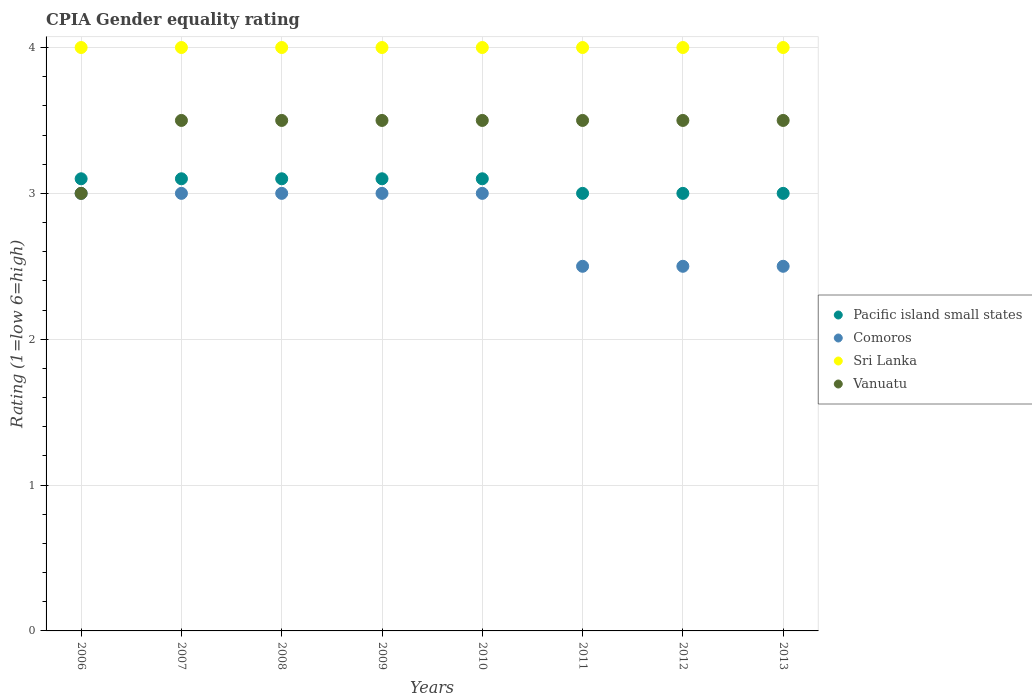What is the CPIA rating in Pacific island small states in 2007?
Your response must be concise. 3.1. What is the difference between the CPIA rating in Pacific island small states in 2010 and the CPIA rating in Vanuatu in 2012?
Provide a succinct answer. -0.4. What is the average CPIA rating in Sri Lanka per year?
Offer a terse response. 4. What is the ratio of the CPIA rating in Sri Lanka in 2009 to that in 2010?
Keep it short and to the point. 1. What is the difference between the highest and the second highest CPIA rating in Pacific island small states?
Provide a short and direct response. 0. What is the difference between the highest and the lowest CPIA rating in Pacific island small states?
Make the answer very short. 0.1. In how many years, is the CPIA rating in Comoros greater than the average CPIA rating in Comoros taken over all years?
Ensure brevity in your answer.  5. Is the CPIA rating in Sri Lanka strictly greater than the CPIA rating in Vanuatu over the years?
Your answer should be very brief. Yes. Is the CPIA rating in Pacific island small states strictly less than the CPIA rating in Comoros over the years?
Make the answer very short. No. How many years are there in the graph?
Provide a succinct answer. 8. What is the difference between two consecutive major ticks on the Y-axis?
Provide a short and direct response. 1. Are the values on the major ticks of Y-axis written in scientific E-notation?
Provide a short and direct response. No. Where does the legend appear in the graph?
Your response must be concise. Center right. How are the legend labels stacked?
Provide a short and direct response. Vertical. What is the title of the graph?
Offer a very short reply. CPIA Gender equality rating. Does "Guam" appear as one of the legend labels in the graph?
Provide a short and direct response. No. What is the label or title of the Y-axis?
Offer a very short reply. Rating (1=low 6=high). What is the Rating (1=low 6=high) in Comoros in 2006?
Provide a succinct answer. 3. What is the Rating (1=low 6=high) of Vanuatu in 2006?
Offer a terse response. 3. What is the Rating (1=low 6=high) in Pacific island small states in 2007?
Provide a short and direct response. 3.1. What is the Rating (1=low 6=high) in Comoros in 2007?
Provide a succinct answer. 3. What is the Rating (1=low 6=high) in Sri Lanka in 2007?
Give a very brief answer. 4. What is the Rating (1=low 6=high) of Pacific island small states in 2008?
Offer a terse response. 3.1. What is the Rating (1=low 6=high) in Comoros in 2008?
Provide a succinct answer. 3. What is the Rating (1=low 6=high) in Vanuatu in 2008?
Provide a succinct answer. 3.5. What is the Rating (1=low 6=high) of Sri Lanka in 2010?
Provide a short and direct response. 4. What is the Rating (1=low 6=high) of Vanuatu in 2010?
Your response must be concise. 3.5. What is the Rating (1=low 6=high) in Pacific island small states in 2011?
Provide a succinct answer. 3. What is the Rating (1=low 6=high) in Sri Lanka in 2011?
Your answer should be compact. 4. What is the Rating (1=low 6=high) of Vanuatu in 2011?
Your response must be concise. 3.5. What is the Rating (1=low 6=high) in Vanuatu in 2012?
Your response must be concise. 3.5. Across all years, what is the maximum Rating (1=low 6=high) in Pacific island small states?
Offer a very short reply. 3.1. Across all years, what is the minimum Rating (1=low 6=high) of Sri Lanka?
Provide a succinct answer. 4. What is the total Rating (1=low 6=high) of Comoros in the graph?
Your response must be concise. 22.5. What is the total Rating (1=low 6=high) of Sri Lanka in the graph?
Offer a terse response. 32. What is the difference between the Rating (1=low 6=high) in Pacific island small states in 2006 and that in 2007?
Offer a terse response. 0. What is the difference between the Rating (1=low 6=high) in Comoros in 2006 and that in 2007?
Provide a succinct answer. 0. What is the difference between the Rating (1=low 6=high) of Pacific island small states in 2006 and that in 2008?
Ensure brevity in your answer.  0. What is the difference between the Rating (1=low 6=high) of Comoros in 2006 and that in 2008?
Provide a short and direct response. 0. What is the difference between the Rating (1=low 6=high) of Vanuatu in 2006 and that in 2008?
Provide a short and direct response. -0.5. What is the difference between the Rating (1=low 6=high) in Pacific island small states in 2006 and that in 2009?
Give a very brief answer. 0. What is the difference between the Rating (1=low 6=high) in Pacific island small states in 2006 and that in 2010?
Keep it short and to the point. 0. What is the difference between the Rating (1=low 6=high) in Pacific island small states in 2006 and that in 2011?
Ensure brevity in your answer.  0.1. What is the difference between the Rating (1=low 6=high) of Vanuatu in 2006 and that in 2011?
Your answer should be compact. -0.5. What is the difference between the Rating (1=low 6=high) of Comoros in 2006 and that in 2012?
Ensure brevity in your answer.  0.5. What is the difference between the Rating (1=low 6=high) of Vanuatu in 2006 and that in 2012?
Provide a succinct answer. -0.5. What is the difference between the Rating (1=low 6=high) in Pacific island small states in 2006 and that in 2013?
Ensure brevity in your answer.  0.1. What is the difference between the Rating (1=low 6=high) of Sri Lanka in 2006 and that in 2013?
Your answer should be compact. 0. What is the difference between the Rating (1=low 6=high) in Comoros in 2007 and that in 2008?
Make the answer very short. 0. What is the difference between the Rating (1=low 6=high) in Pacific island small states in 2007 and that in 2009?
Make the answer very short. 0. What is the difference between the Rating (1=low 6=high) of Vanuatu in 2007 and that in 2009?
Ensure brevity in your answer.  0. What is the difference between the Rating (1=low 6=high) in Pacific island small states in 2007 and that in 2010?
Offer a very short reply. 0. What is the difference between the Rating (1=low 6=high) in Sri Lanka in 2007 and that in 2010?
Your answer should be very brief. 0. What is the difference between the Rating (1=low 6=high) of Sri Lanka in 2007 and that in 2011?
Provide a short and direct response. 0. What is the difference between the Rating (1=low 6=high) of Vanuatu in 2007 and that in 2011?
Your answer should be very brief. 0. What is the difference between the Rating (1=low 6=high) of Sri Lanka in 2007 and that in 2012?
Provide a short and direct response. 0. What is the difference between the Rating (1=low 6=high) of Vanuatu in 2007 and that in 2012?
Your response must be concise. 0. What is the difference between the Rating (1=low 6=high) of Pacific island small states in 2007 and that in 2013?
Your answer should be compact. 0.1. What is the difference between the Rating (1=low 6=high) in Sri Lanka in 2007 and that in 2013?
Offer a terse response. 0. What is the difference between the Rating (1=low 6=high) in Comoros in 2008 and that in 2009?
Keep it short and to the point. 0. What is the difference between the Rating (1=low 6=high) in Sri Lanka in 2008 and that in 2010?
Your answer should be compact. 0. What is the difference between the Rating (1=low 6=high) in Vanuatu in 2008 and that in 2010?
Offer a terse response. 0. What is the difference between the Rating (1=low 6=high) in Pacific island small states in 2008 and that in 2011?
Ensure brevity in your answer.  0.1. What is the difference between the Rating (1=low 6=high) in Comoros in 2008 and that in 2011?
Your answer should be compact. 0.5. What is the difference between the Rating (1=low 6=high) of Comoros in 2008 and that in 2012?
Give a very brief answer. 0.5. What is the difference between the Rating (1=low 6=high) of Sri Lanka in 2008 and that in 2012?
Provide a succinct answer. 0. What is the difference between the Rating (1=low 6=high) in Pacific island small states in 2009 and that in 2010?
Provide a short and direct response. 0. What is the difference between the Rating (1=low 6=high) in Comoros in 2009 and that in 2010?
Offer a terse response. 0. What is the difference between the Rating (1=low 6=high) of Vanuatu in 2009 and that in 2010?
Your answer should be compact. 0. What is the difference between the Rating (1=low 6=high) in Pacific island small states in 2009 and that in 2011?
Ensure brevity in your answer.  0.1. What is the difference between the Rating (1=low 6=high) in Comoros in 2009 and that in 2011?
Keep it short and to the point. 0.5. What is the difference between the Rating (1=low 6=high) of Vanuatu in 2009 and that in 2011?
Give a very brief answer. 0. What is the difference between the Rating (1=low 6=high) in Pacific island small states in 2009 and that in 2012?
Keep it short and to the point. 0.1. What is the difference between the Rating (1=low 6=high) in Sri Lanka in 2009 and that in 2012?
Your answer should be very brief. 0. What is the difference between the Rating (1=low 6=high) of Vanuatu in 2009 and that in 2012?
Give a very brief answer. 0. What is the difference between the Rating (1=low 6=high) of Pacific island small states in 2009 and that in 2013?
Offer a terse response. 0.1. What is the difference between the Rating (1=low 6=high) in Comoros in 2009 and that in 2013?
Make the answer very short. 0.5. What is the difference between the Rating (1=low 6=high) in Sri Lanka in 2009 and that in 2013?
Provide a short and direct response. 0. What is the difference between the Rating (1=low 6=high) of Vanuatu in 2009 and that in 2013?
Provide a short and direct response. 0. What is the difference between the Rating (1=low 6=high) of Pacific island small states in 2010 and that in 2011?
Give a very brief answer. 0.1. What is the difference between the Rating (1=low 6=high) of Comoros in 2010 and that in 2011?
Give a very brief answer. 0.5. What is the difference between the Rating (1=low 6=high) of Sri Lanka in 2010 and that in 2011?
Ensure brevity in your answer.  0. What is the difference between the Rating (1=low 6=high) in Pacific island small states in 2010 and that in 2012?
Your response must be concise. 0.1. What is the difference between the Rating (1=low 6=high) of Sri Lanka in 2010 and that in 2012?
Your response must be concise. 0. What is the difference between the Rating (1=low 6=high) of Vanuatu in 2010 and that in 2012?
Keep it short and to the point. 0. What is the difference between the Rating (1=low 6=high) of Pacific island small states in 2010 and that in 2013?
Ensure brevity in your answer.  0.1. What is the difference between the Rating (1=low 6=high) in Vanuatu in 2010 and that in 2013?
Provide a succinct answer. 0. What is the difference between the Rating (1=low 6=high) of Vanuatu in 2011 and that in 2013?
Your response must be concise. 0. What is the difference between the Rating (1=low 6=high) of Pacific island small states in 2012 and that in 2013?
Make the answer very short. 0. What is the difference between the Rating (1=low 6=high) in Vanuatu in 2012 and that in 2013?
Make the answer very short. 0. What is the difference between the Rating (1=low 6=high) in Pacific island small states in 2006 and the Rating (1=low 6=high) in Comoros in 2007?
Ensure brevity in your answer.  0.1. What is the difference between the Rating (1=low 6=high) in Pacific island small states in 2006 and the Rating (1=low 6=high) in Vanuatu in 2007?
Your answer should be very brief. -0.4. What is the difference between the Rating (1=low 6=high) of Pacific island small states in 2006 and the Rating (1=low 6=high) of Comoros in 2008?
Your answer should be compact. 0.1. What is the difference between the Rating (1=low 6=high) in Pacific island small states in 2006 and the Rating (1=low 6=high) in Vanuatu in 2008?
Give a very brief answer. -0.4. What is the difference between the Rating (1=low 6=high) of Comoros in 2006 and the Rating (1=low 6=high) of Sri Lanka in 2009?
Ensure brevity in your answer.  -1. What is the difference between the Rating (1=low 6=high) of Comoros in 2006 and the Rating (1=low 6=high) of Vanuatu in 2009?
Your answer should be very brief. -0.5. What is the difference between the Rating (1=low 6=high) of Sri Lanka in 2006 and the Rating (1=low 6=high) of Vanuatu in 2009?
Offer a terse response. 0.5. What is the difference between the Rating (1=low 6=high) of Pacific island small states in 2006 and the Rating (1=low 6=high) of Vanuatu in 2010?
Offer a terse response. -0.4. What is the difference between the Rating (1=low 6=high) of Comoros in 2006 and the Rating (1=low 6=high) of Sri Lanka in 2010?
Your response must be concise. -1. What is the difference between the Rating (1=low 6=high) in Comoros in 2006 and the Rating (1=low 6=high) in Vanuatu in 2010?
Make the answer very short. -0.5. What is the difference between the Rating (1=low 6=high) in Sri Lanka in 2006 and the Rating (1=low 6=high) in Vanuatu in 2010?
Make the answer very short. 0.5. What is the difference between the Rating (1=low 6=high) of Pacific island small states in 2006 and the Rating (1=low 6=high) of Comoros in 2011?
Offer a very short reply. 0.6. What is the difference between the Rating (1=low 6=high) in Comoros in 2006 and the Rating (1=low 6=high) in Vanuatu in 2011?
Keep it short and to the point. -0.5. What is the difference between the Rating (1=low 6=high) in Sri Lanka in 2006 and the Rating (1=low 6=high) in Vanuatu in 2011?
Your answer should be compact. 0.5. What is the difference between the Rating (1=low 6=high) in Sri Lanka in 2006 and the Rating (1=low 6=high) in Vanuatu in 2012?
Provide a short and direct response. 0.5. What is the difference between the Rating (1=low 6=high) of Pacific island small states in 2006 and the Rating (1=low 6=high) of Comoros in 2013?
Provide a short and direct response. 0.6. What is the difference between the Rating (1=low 6=high) of Pacific island small states in 2007 and the Rating (1=low 6=high) of Vanuatu in 2008?
Provide a short and direct response. -0.4. What is the difference between the Rating (1=low 6=high) of Sri Lanka in 2007 and the Rating (1=low 6=high) of Vanuatu in 2008?
Your answer should be very brief. 0.5. What is the difference between the Rating (1=low 6=high) of Pacific island small states in 2007 and the Rating (1=low 6=high) of Comoros in 2009?
Give a very brief answer. 0.1. What is the difference between the Rating (1=low 6=high) in Pacific island small states in 2007 and the Rating (1=low 6=high) in Sri Lanka in 2009?
Offer a terse response. -0.9. What is the difference between the Rating (1=low 6=high) in Pacific island small states in 2007 and the Rating (1=low 6=high) in Vanuatu in 2009?
Provide a succinct answer. -0.4. What is the difference between the Rating (1=low 6=high) in Pacific island small states in 2007 and the Rating (1=low 6=high) in Comoros in 2010?
Give a very brief answer. 0.1. What is the difference between the Rating (1=low 6=high) in Pacific island small states in 2007 and the Rating (1=low 6=high) in Sri Lanka in 2010?
Keep it short and to the point. -0.9. What is the difference between the Rating (1=low 6=high) of Pacific island small states in 2007 and the Rating (1=low 6=high) of Comoros in 2011?
Your answer should be very brief. 0.6. What is the difference between the Rating (1=low 6=high) of Pacific island small states in 2007 and the Rating (1=low 6=high) of Vanuatu in 2011?
Your answer should be compact. -0.4. What is the difference between the Rating (1=low 6=high) of Pacific island small states in 2007 and the Rating (1=low 6=high) of Comoros in 2012?
Your answer should be very brief. 0.6. What is the difference between the Rating (1=low 6=high) of Pacific island small states in 2007 and the Rating (1=low 6=high) of Sri Lanka in 2012?
Offer a terse response. -0.9. What is the difference between the Rating (1=low 6=high) of Pacific island small states in 2007 and the Rating (1=low 6=high) of Vanuatu in 2012?
Provide a succinct answer. -0.4. What is the difference between the Rating (1=low 6=high) of Comoros in 2007 and the Rating (1=low 6=high) of Sri Lanka in 2012?
Ensure brevity in your answer.  -1. What is the difference between the Rating (1=low 6=high) of Comoros in 2007 and the Rating (1=low 6=high) of Vanuatu in 2012?
Provide a short and direct response. -0.5. What is the difference between the Rating (1=low 6=high) in Sri Lanka in 2007 and the Rating (1=low 6=high) in Vanuatu in 2012?
Your answer should be compact. 0.5. What is the difference between the Rating (1=low 6=high) of Pacific island small states in 2007 and the Rating (1=low 6=high) of Comoros in 2013?
Your answer should be very brief. 0.6. What is the difference between the Rating (1=low 6=high) in Pacific island small states in 2007 and the Rating (1=low 6=high) in Sri Lanka in 2013?
Provide a succinct answer. -0.9. What is the difference between the Rating (1=low 6=high) in Pacific island small states in 2007 and the Rating (1=low 6=high) in Vanuatu in 2013?
Give a very brief answer. -0.4. What is the difference between the Rating (1=low 6=high) in Comoros in 2007 and the Rating (1=low 6=high) in Sri Lanka in 2013?
Make the answer very short. -1. What is the difference between the Rating (1=low 6=high) in Comoros in 2007 and the Rating (1=low 6=high) in Vanuatu in 2013?
Your response must be concise. -0.5. What is the difference between the Rating (1=low 6=high) in Sri Lanka in 2007 and the Rating (1=low 6=high) in Vanuatu in 2013?
Give a very brief answer. 0.5. What is the difference between the Rating (1=low 6=high) of Pacific island small states in 2008 and the Rating (1=low 6=high) of Comoros in 2009?
Offer a very short reply. 0.1. What is the difference between the Rating (1=low 6=high) in Pacific island small states in 2008 and the Rating (1=low 6=high) in Sri Lanka in 2009?
Your answer should be very brief. -0.9. What is the difference between the Rating (1=low 6=high) in Pacific island small states in 2008 and the Rating (1=low 6=high) in Vanuatu in 2009?
Your response must be concise. -0.4. What is the difference between the Rating (1=low 6=high) in Sri Lanka in 2008 and the Rating (1=low 6=high) in Vanuatu in 2009?
Ensure brevity in your answer.  0.5. What is the difference between the Rating (1=low 6=high) in Comoros in 2008 and the Rating (1=low 6=high) in Vanuatu in 2010?
Give a very brief answer. -0.5. What is the difference between the Rating (1=low 6=high) in Pacific island small states in 2008 and the Rating (1=low 6=high) in Comoros in 2011?
Make the answer very short. 0.6. What is the difference between the Rating (1=low 6=high) of Comoros in 2008 and the Rating (1=low 6=high) of Sri Lanka in 2011?
Provide a succinct answer. -1. What is the difference between the Rating (1=low 6=high) in Comoros in 2008 and the Rating (1=low 6=high) in Vanuatu in 2011?
Offer a terse response. -0.5. What is the difference between the Rating (1=low 6=high) of Sri Lanka in 2008 and the Rating (1=low 6=high) of Vanuatu in 2011?
Provide a succinct answer. 0.5. What is the difference between the Rating (1=low 6=high) of Pacific island small states in 2008 and the Rating (1=low 6=high) of Comoros in 2012?
Provide a short and direct response. 0.6. What is the difference between the Rating (1=low 6=high) in Pacific island small states in 2008 and the Rating (1=low 6=high) in Sri Lanka in 2012?
Give a very brief answer. -0.9. What is the difference between the Rating (1=low 6=high) of Pacific island small states in 2008 and the Rating (1=low 6=high) of Vanuatu in 2012?
Offer a very short reply. -0.4. What is the difference between the Rating (1=low 6=high) in Sri Lanka in 2008 and the Rating (1=low 6=high) in Vanuatu in 2012?
Your response must be concise. 0.5. What is the difference between the Rating (1=low 6=high) in Pacific island small states in 2008 and the Rating (1=low 6=high) in Comoros in 2013?
Your answer should be compact. 0.6. What is the difference between the Rating (1=low 6=high) of Pacific island small states in 2008 and the Rating (1=low 6=high) of Sri Lanka in 2013?
Give a very brief answer. -0.9. What is the difference between the Rating (1=low 6=high) in Pacific island small states in 2008 and the Rating (1=low 6=high) in Vanuatu in 2013?
Offer a very short reply. -0.4. What is the difference between the Rating (1=low 6=high) in Comoros in 2008 and the Rating (1=low 6=high) in Vanuatu in 2013?
Your answer should be compact. -0.5. What is the difference between the Rating (1=low 6=high) in Comoros in 2009 and the Rating (1=low 6=high) in Sri Lanka in 2010?
Your answer should be very brief. -1. What is the difference between the Rating (1=low 6=high) of Comoros in 2009 and the Rating (1=low 6=high) of Vanuatu in 2010?
Keep it short and to the point. -0.5. What is the difference between the Rating (1=low 6=high) of Sri Lanka in 2009 and the Rating (1=low 6=high) of Vanuatu in 2010?
Give a very brief answer. 0.5. What is the difference between the Rating (1=low 6=high) of Pacific island small states in 2009 and the Rating (1=low 6=high) of Vanuatu in 2011?
Offer a very short reply. -0.4. What is the difference between the Rating (1=low 6=high) in Comoros in 2009 and the Rating (1=low 6=high) in Sri Lanka in 2011?
Offer a very short reply. -1. What is the difference between the Rating (1=low 6=high) in Pacific island small states in 2009 and the Rating (1=low 6=high) in Comoros in 2012?
Make the answer very short. 0.6. What is the difference between the Rating (1=low 6=high) of Pacific island small states in 2009 and the Rating (1=low 6=high) of Vanuatu in 2012?
Your answer should be very brief. -0.4. What is the difference between the Rating (1=low 6=high) of Sri Lanka in 2009 and the Rating (1=low 6=high) of Vanuatu in 2012?
Your answer should be compact. 0.5. What is the difference between the Rating (1=low 6=high) in Pacific island small states in 2009 and the Rating (1=low 6=high) in Sri Lanka in 2013?
Give a very brief answer. -0.9. What is the difference between the Rating (1=low 6=high) in Pacific island small states in 2009 and the Rating (1=low 6=high) in Vanuatu in 2013?
Give a very brief answer. -0.4. What is the difference between the Rating (1=low 6=high) in Comoros in 2009 and the Rating (1=low 6=high) in Sri Lanka in 2013?
Your answer should be compact. -1. What is the difference between the Rating (1=low 6=high) of Sri Lanka in 2009 and the Rating (1=low 6=high) of Vanuatu in 2013?
Keep it short and to the point. 0.5. What is the difference between the Rating (1=low 6=high) in Pacific island small states in 2010 and the Rating (1=low 6=high) in Comoros in 2011?
Provide a succinct answer. 0.6. What is the difference between the Rating (1=low 6=high) in Comoros in 2010 and the Rating (1=low 6=high) in Sri Lanka in 2011?
Offer a terse response. -1. What is the difference between the Rating (1=low 6=high) in Pacific island small states in 2010 and the Rating (1=low 6=high) in Comoros in 2012?
Give a very brief answer. 0.6. What is the difference between the Rating (1=low 6=high) in Pacific island small states in 2010 and the Rating (1=low 6=high) in Sri Lanka in 2012?
Your answer should be compact. -0.9. What is the difference between the Rating (1=low 6=high) of Comoros in 2010 and the Rating (1=low 6=high) of Sri Lanka in 2012?
Offer a terse response. -1. What is the difference between the Rating (1=low 6=high) in Pacific island small states in 2010 and the Rating (1=low 6=high) in Comoros in 2013?
Make the answer very short. 0.6. What is the difference between the Rating (1=low 6=high) in Pacific island small states in 2010 and the Rating (1=low 6=high) in Vanuatu in 2013?
Make the answer very short. -0.4. What is the difference between the Rating (1=low 6=high) of Comoros in 2010 and the Rating (1=low 6=high) of Vanuatu in 2013?
Provide a succinct answer. -0.5. What is the difference between the Rating (1=low 6=high) of Sri Lanka in 2010 and the Rating (1=low 6=high) of Vanuatu in 2013?
Your answer should be very brief. 0.5. What is the difference between the Rating (1=low 6=high) of Pacific island small states in 2011 and the Rating (1=low 6=high) of Comoros in 2012?
Give a very brief answer. 0.5. What is the difference between the Rating (1=low 6=high) in Pacific island small states in 2011 and the Rating (1=low 6=high) in Comoros in 2013?
Your response must be concise. 0.5. What is the difference between the Rating (1=low 6=high) in Pacific island small states in 2011 and the Rating (1=low 6=high) in Vanuatu in 2013?
Offer a terse response. -0.5. What is the difference between the Rating (1=low 6=high) in Comoros in 2011 and the Rating (1=low 6=high) in Vanuatu in 2013?
Your response must be concise. -1. What is the difference between the Rating (1=low 6=high) of Pacific island small states in 2012 and the Rating (1=low 6=high) of Comoros in 2013?
Your answer should be compact. 0.5. What is the difference between the Rating (1=low 6=high) in Pacific island small states in 2012 and the Rating (1=low 6=high) in Sri Lanka in 2013?
Your response must be concise. -1. What is the difference between the Rating (1=low 6=high) in Sri Lanka in 2012 and the Rating (1=low 6=high) in Vanuatu in 2013?
Ensure brevity in your answer.  0.5. What is the average Rating (1=low 6=high) of Pacific island small states per year?
Make the answer very short. 3.06. What is the average Rating (1=low 6=high) of Comoros per year?
Your answer should be very brief. 2.81. What is the average Rating (1=low 6=high) of Vanuatu per year?
Offer a terse response. 3.44. In the year 2006, what is the difference between the Rating (1=low 6=high) in Pacific island small states and Rating (1=low 6=high) in Sri Lanka?
Your response must be concise. -0.9. In the year 2006, what is the difference between the Rating (1=low 6=high) in Comoros and Rating (1=low 6=high) in Vanuatu?
Provide a short and direct response. 0. In the year 2007, what is the difference between the Rating (1=low 6=high) in Pacific island small states and Rating (1=low 6=high) in Sri Lanka?
Keep it short and to the point. -0.9. In the year 2007, what is the difference between the Rating (1=low 6=high) of Comoros and Rating (1=low 6=high) of Sri Lanka?
Your response must be concise. -1. In the year 2007, what is the difference between the Rating (1=low 6=high) of Comoros and Rating (1=low 6=high) of Vanuatu?
Provide a short and direct response. -0.5. In the year 2008, what is the difference between the Rating (1=low 6=high) of Pacific island small states and Rating (1=low 6=high) of Comoros?
Make the answer very short. 0.1. In the year 2008, what is the difference between the Rating (1=low 6=high) of Pacific island small states and Rating (1=low 6=high) of Sri Lanka?
Give a very brief answer. -0.9. In the year 2008, what is the difference between the Rating (1=low 6=high) of Comoros and Rating (1=low 6=high) of Vanuatu?
Make the answer very short. -0.5. In the year 2009, what is the difference between the Rating (1=low 6=high) in Pacific island small states and Rating (1=low 6=high) in Sri Lanka?
Provide a short and direct response. -0.9. In the year 2009, what is the difference between the Rating (1=low 6=high) of Comoros and Rating (1=low 6=high) of Sri Lanka?
Your answer should be very brief. -1. In the year 2009, what is the difference between the Rating (1=low 6=high) in Comoros and Rating (1=low 6=high) in Vanuatu?
Make the answer very short. -0.5. In the year 2009, what is the difference between the Rating (1=low 6=high) in Sri Lanka and Rating (1=low 6=high) in Vanuatu?
Give a very brief answer. 0.5. In the year 2010, what is the difference between the Rating (1=low 6=high) in Comoros and Rating (1=low 6=high) in Sri Lanka?
Your response must be concise. -1. In the year 2011, what is the difference between the Rating (1=low 6=high) of Pacific island small states and Rating (1=low 6=high) of Sri Lanka?
Your answer should be compact. -1. In the year 2011, what is the difference between the Rating (1=low 6=high) in Pacific island small states and Rating (1=low 6=high) in Vanuatu?
Ensure brevity in your answer.  -0.5. In the year 2011, what is the difference between the Rating (1=low 6=high) of Comoros and Rating (1=low 6=high) of Sri Lanka?
Provide a succinct answer. -1.5. In the year 2011, what is the difference between the Rating (1=low 6=high) of Comoros and Rating (1=low 6=high) of Vanuatu?
Make the answer very short. -1. In the year 2011, what is the difference between the Rating (1=low 6=high) of Sri Lanka and Rating (1=low 6=high) of Vanuatu?
Give a very brief answer. 0.5. In the year 2012, what is the difference between the Rating (1=low 6=high) in Pacific island small states and Rating (1=low 6=high) in Vanuatu?
Provide a succinct answer. -0.5. In the year 2012, what is the difference between the Rating (1=low 6=high) of Comoros and Rating (1=low 6=high) of Sri Lanka?
Offer a terse response. -1.5. In the year 2012, what is the difference between the Rating (1=low 6=high) in Comoros and Rating (1=low 6=high) in Vanuatu?
Ensure brevity in your answer.  -1. In the year 2012, what is the difference between the Rating (1=low 6=high) of Sri Lanka and Rating (1=low 6=high) of Vanuatu?
Your answer should be very brief. 0.5. In the year 2013, what is the difference between the Rating (1=low 6=high) of Pacific island small states and Rating (1=low 6=high) of Vanuatu?
Your answer should be compact. -0.5. In the year 2013, what is the difference between the Rating (1=low 6=high) of Comoros and Rating (1=low 6=high) of Vanuatu?
Make the answer very short. -1. In the year 2013, what is the difference between the Rating (1=low 6=high) of Sri Lanka and Rating (1=low 6=high) of Vanuatu?
Your answer should be compact. 0.5. What is the ratio of the Rating (1=low 6=high) in Comoros in 2006 to that in 2007?
Give a very brief answer. 1. What is the ratio of the Rating (1=low 6=high) of Sri Lanka in 2006 to that in 2007?
Your answer should be very brief. 1. What is the ratio of the Rating (1=low 6=high) of Vanuatu in 2006 to that in 2008?
Provide a short and direct response. 0.86. What is the ratio of the Rating (1=low 6=high) in Comoros in 2006 to that in 2009?
Offer a terse response. 1. What is the ratio of the Rating (1=low 6=high) of Vanuatu in 2006 to that in 2009?
Your response must be concise. 0.86. What is the ratio of the Rating (1=low 6=high) of Comoros in 2006 to that in 2010?
Keep it short and to the point. 1. What is the ratio of the Rating (1=low 6=high) of Pacific island small states in 2006 to that in 2011?
Your response must be concise. 1.03. What is the ratio of the Rating (1=low 6=high) in Sri Lanka in 2006 to that in 2011?
Give a very brief answer. 1. What is the ratio of the Rating (1=low 6=high) of Sri Lanka in 2006 to that in 2012?
Your answer should be very brief. 1. What is the ratio of the Rating (1=low 6=high) of Comoros in 2006 to that in 2013?
Provide a succinct answer. 1.2. What is the ratio of the Rating (1=low 6=high) in Vanuatu in 2006 to that in 2013?
Offer a terse response. 0.86. What is the ratio of the Rating (1=low 6=high) of Pacific island small states in 2007 to that in 2008?
Make the answer very short. 1. What is the ratio of the Rating (1=low 6=high) in Vanuatu in 2007 to that in 2008?
Provide a succinct answer. 1. What is the ratio of the Rating (1=low 6=high) in Pacific island small states in 2007 to that in 2009?
Offer a very short reply. 1. What is the ratio of the Rating (1=low 6=high) in Comoros in 2007 to that in 2009?
Your answer should be very brief. 1. What is the ratio of the Rating (1=low 6=high) in Sri Lanka in 2007 to that in 2009?
Provide a succinct answer. 1. What is the ratio of the Rating (1=low 6=high) in Comoros in 2007 to that in 2010?
Your answer should be compact. 1. What is the ratio of the Rating (1=low 6=high) in Sri Lanka in 2007 to that in 2010?
Make the answer very short. 1. What is the ratio of the Rating (1=low 6=high) in Vanuatu in 2007 to that in 2010?
Offer a very short reply. 1. What is the ratio of the Rating (1=low 6=high) of Vanuatu in 2007 to that in 2011?
Your answer should be compact. 1. What is the ratio of the Rating (1=low 6=high) of Comoros in 2007 to that in 2013?
Keep it short and to the point. 1.2. What is the ratio of the Rating (1=low 6=high) in Vanuatu in 2007 to that in 2013?
Offer a very short reply. 1. What is the ratio of the Rating (1=low 6=high) of Pacific island small states in 2008 to that in 2009?
Ensure brevity in your answer.  1. What is the ratio of the Rating (1=low 6=high) of Sri Lanka in 2008 to that in 2009?
Give a very brief answer. 1. What is the ratio of the Rating (1=low 6=high) in Vanuatu in 2008 to that in 2009?
Provide a succinct answer. 1. What is the ratio of the Rating (1=low 6=high) of Pacific island small states in 2008 to that in 2010?
Your answer should be compact. 1. What is the ratio of the Rating (1=low 6=high) in Comoros in 2008 to that in 2010?
Your response must be concise. 1. What is the ratio of the Rating (1=low 6=high) of Sri Lanka in 2008 to that in 2010?
Offer a very short reply. 1. What is the ratio of the Rating (1=low 6=high) in Comoros in 2008 to that in 2011?
Make the answer very short. 1.2. What is the ratio of the Rating (1=low 6=high) in Vanuatu in 2008 to that in 2011?
Ensure brevity in your answer.  1. What is the ratio of the Rating (1=low 6=high) of Comoros in 2008 to that in 2012?
Ensure brevity in your answer.  1.2. What is the ratio of the Rating (1=low 6=high) of Comoros in 2008 to that in 2013?
Give a very brief answer. 1.2. What is the ratio of the Rating (1=low 6=high) in Sri Lanka in 2008 to that in 2013?
Your response must be concise. 1. What is the ratio of the Rating (1=low 6=high) of Pacific island small states in 2009 to that in 2011?
Give a very brief answer. 1.03. What is the ratio of the Rating (1=low 6=high) of Sri Lanka in 2009 to that in 2011?
Make the answer very short. 1. What is the ratio of the Rating (1=low 6=high) of Vanuatu in 2009 to that in 2011?
Give a very brief answer. 1. What is the ratio of the Rating (1=low 6=high) of Pacific island small states in 2009 to that in 2012?
Offer a very short reply. 1.03. What is the ratio of the Rating (1=low 6=high) in Sri Lanka in 2009 to that in 2012?
Ensure brevity in your answer.  1. What is the ratio of the Rating (1=low 6=high) of Vanuatu in 2009 to that in 2012?
Keep it short and to the point. 1. What is the ratio of the Rating (1=low 6=high) in Pacific island small states in 2009 to that in 2013?
Provide a succinct answer. 1.03. What is the ratio of the Rating (1=low 6=high) of Sri Lanka in 2009 to that in 2013?
Make the answer very short. 1. What is the ratio of the Rating (1=low 6=high) in Vanuatu in 2009 to that in 2013?
Provide a short and direct response. 1. What is the ratio of the Rating (1=low 6=high) in Pacific island small states in 2010 to that in 2011?
Offer a very short reply. 1.03. What is the ratio of the Rating (1=low 6=high) of Comoros in 2010 to that in 2011?
Keep it short and to the point. 1.2. What is the ratio of the Rating (1=low 6=high) of Vanuatu in 2010 to that in 2011?
Make the answer very short. 1. What is the ratio of the Rating (1=low 6=high) in Pacific island small states in 2010 to that in 2012?
Your answer should be very brief. 1.03. What is the ratio of the Rating (1=low 6=high) in Sri Lanka in 2010 to that in 2012?
Give a very brief answer. 1. What is the ratio of the Rating (1=low 6=high) in Pacific island small states in 2010 to that in 2013?
Offer a very short reply. 1.03. What is the ratio of the Rating (1=low 6=high) in Sri Lanka in 2010 to that in 2013?
Offer a terse response. 1. What is the ratio of the Rating (1=low 6=high) in Pacific island small states in 2011 to that in 2012?
Offer a terse response. 1. What is the ratio of the Rating (1=low 6=high) of Comoros in 2011 to that in 2012?
Provide a succinct answer. 1. What is the ratio of the Rating (1=low 6=high) in Vanuatu in 2011 to that in 2012?
Your answer should be compact. 1. What is the ratio of the Rating (1=low 6=high) in Comoros in 2012 to that in 2013?
Make the answer very short. 1. What is the ratio of the Rating (1=low 6=high) in Sri Lanka in 2012 to that in 2013?
Offer a terse response. 1. What is the ratio of the Rating (1=low 6=high) in Vanuatu in 2012 to that in 2013?
Your response must be concise. 1. What is the difference between the highest and the second highest Rating (1=low 6=high) in Pacific island small states?
Offer a very short reply. 0. What is the difference between the highest and the lowest Rating (1=low 6=high) of Pacific island small states?
Make the answer very short. 0.1. 